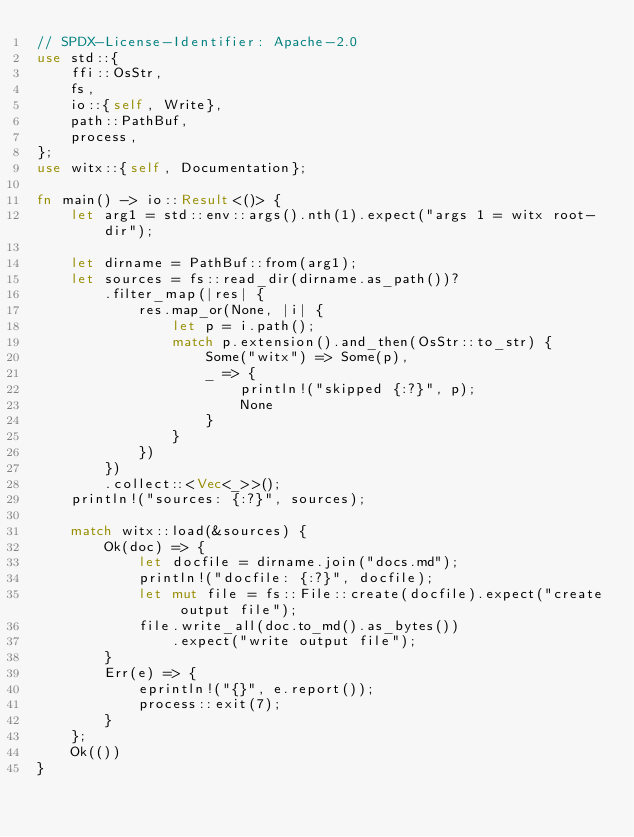Convert code to text. <code><loc_0><loc_0><loc_500><loc_500><_Rust_>// SPDX-License-Identifier: Apache-2.0
use std::{
    ffi::OsStr,
    fs,
    io::{self, Write},
    path::PathBuf,
    process,
};
use witx::{self, Documentation};

fn main() -> io::Result<()> {
    let arg1 = std::env::args().nth(1).expect("args 1 = witx root-dir");

    let dirname = PathBuf::from(arg1);
    let sources = fs::read_dir(dirname.as_path())?
        .filter_map(|res| {
            res.map_or(None, |i| {
                let p = i.path();
                match p.extension().and_then(OsStr::to_str) {
                    Some("witx") => Some(p),
                    _ => {
                        println!("skipped {:?}", p);
                        None
                    }
                }
            })
        })
        .collect::<Vec<_>>();
    println!("sources: {:?}", sources);

    match witx::load(&sources) {
        Ok(doc) => {
            let docfile = dirname.join("docs.md");
            println!("docfile: {:?}", docfile);
            let mut file = fs::File::create(docfile).expect("create output file");
            file.write_all(doc.to_md().as_bytes())
                .expect("write output file");
        }
        Err(e) => {
            eprintln!("{}", e.report());
            process::exit(7);
        }
    };
    Ok(())
}
</code> 